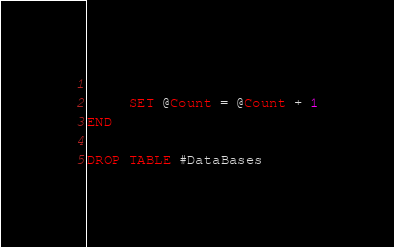<code> <loc_0><loc_0><loc_500><loc_500><_SQL_>     
     SET @Count = @Count + 1
END

DROP TABLE #DataBases
</code> 